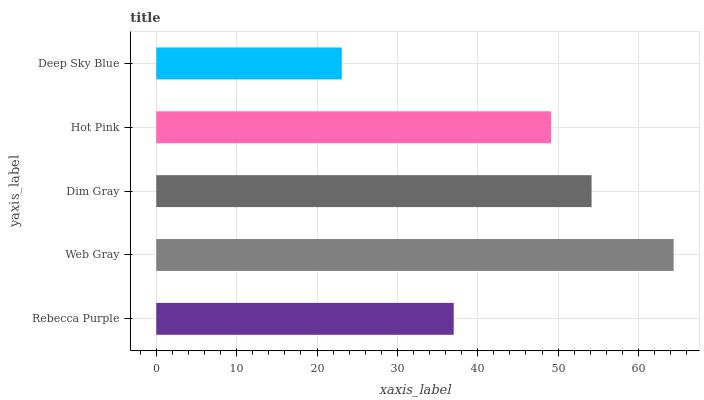Is Deep Sky Blue the minimum?
Answer yes or no. Yes. Is Web Gray the maximum?
Answer yes or no. Yes. Is Dim Gray the minimum?
Answer yes or no. No. Is Dim Gray the maximum?
Answer yes or no. No. Is Web Gray greater than Dim Gray?
Answer yes or no. Yes. Is Dim Gray less than Web Gray?
Answer yes or no. Yes. Is Dim Gray greater than Web Gray?
Answer yes or no. No. Is Web Gray less than Dim Gray?
Answer yes or no. No. Is Hot Pink the high median?
Answer yes or no. Yes. Is Hot Pink the low median?
Answer yes or no. Yes. Is Rebecca Purple the high median?
Answer yes or no. No. Is Deep Sky Blue the low median?
Answer yes or no. No. 